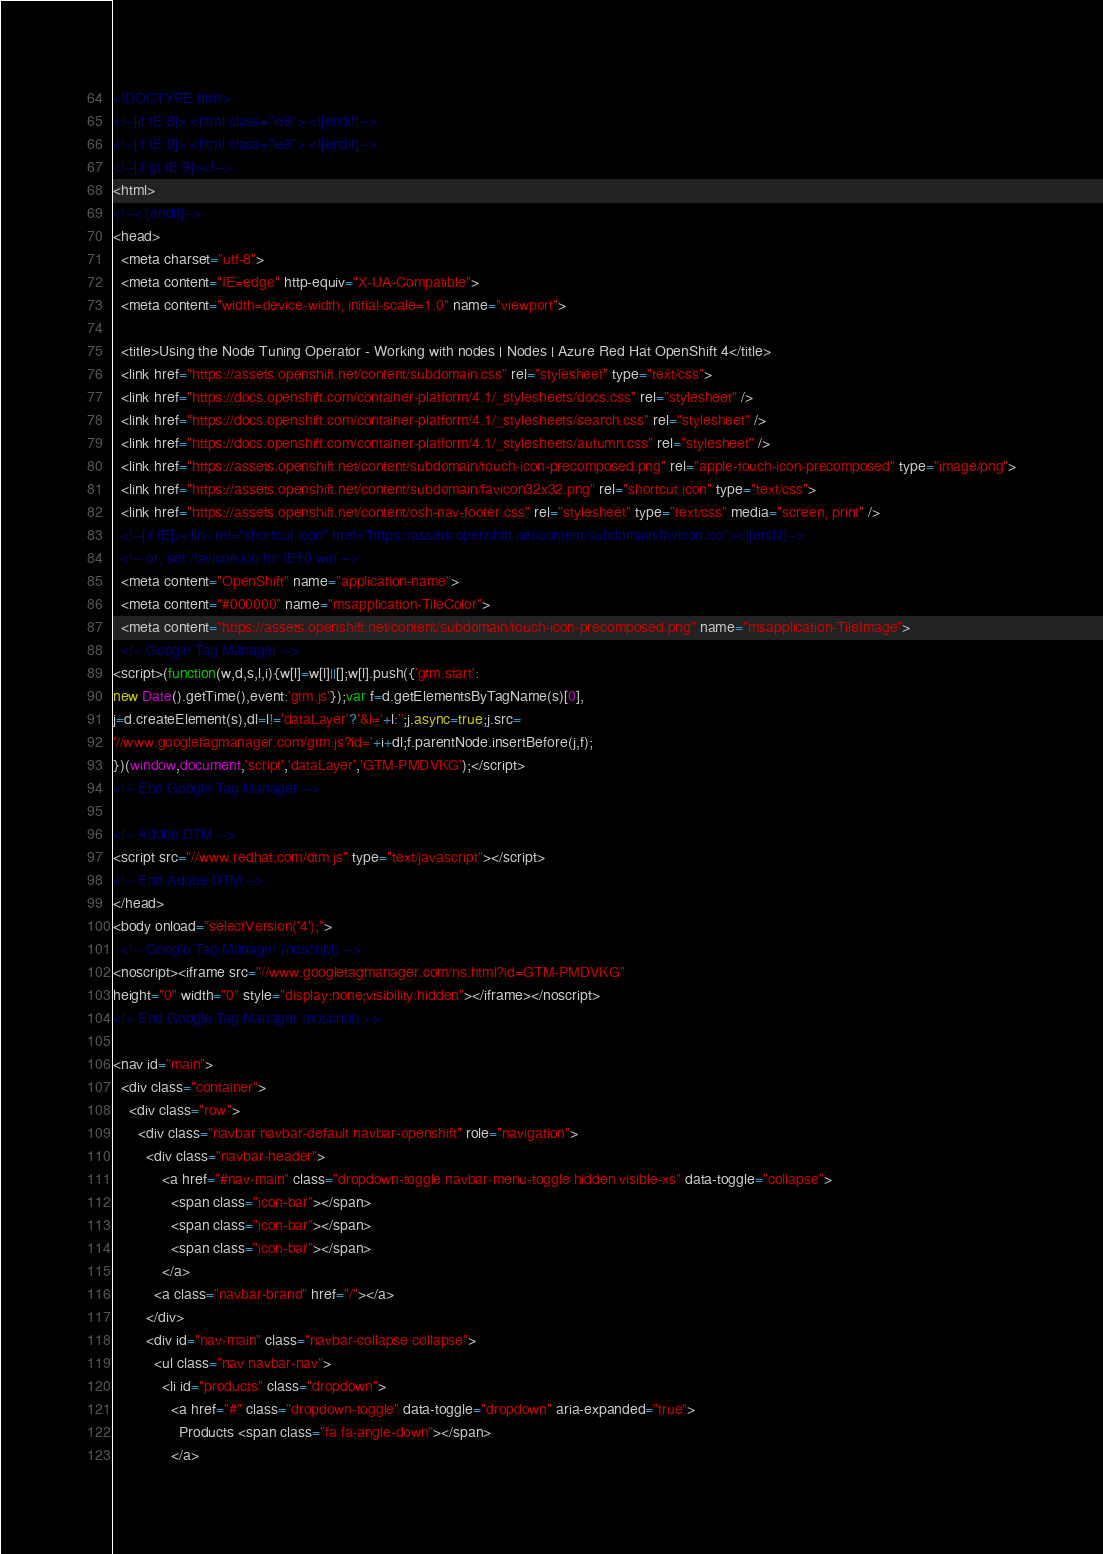Convert code to text. <code><loc_0><loc_0><loc_500><loc_500><_HTML_>

<!DOCTYPE html>
<!--[if IE 8]> <html class="ie8"> <![endif]-->
<!--[if IE 9]> <html class="ie9"> <![endif]-->
<!--[if gt IE 9]><!-->
<html>
<!--<![endif]-->
<head>
  <meta charset="utf-8">
  <meta content="IE=edge" http-equiv="X-UA-Compatible">
  <meta content="width=device-width, initial-scale=1.0" name="viewport">
  
  <title>Using the Node Tuning Operator - Working with nodes | Nodes | Azure Red Hat OpenShift 4</title>
  <link href="https://assets.openshift.net/content/subdomain.css" rel="stylesheet" type="text/css">
  <link href="https://docs.openshift.com/container-platform/4.1/_stylesheets/docs.css" rel="stylesheet" />
  <link href="https://docs.openshift.com/container-platform/4.1/_stylesheets/search.css" rel="stylesheet" />
  <link href="https://docs.openshift.com/container-platform/4.1/_stylesheets/autumn.css" rel="stylesheet" />
  <link href="https://assets.openshift.net/content/subdomain/touch-icon-precomposed.png" rel="apple-touch-icon-precomposed" type="image/png">
  <link href="https://assets.openshift.net/content/subdomain/favicon32x32.png" rel="shortcut icon" type="text/css">
  <link href="https://assets.openshift.net/content/osh-nav-footer.css" rel="stylesheet" type="text/css" media="screen, print" />
  <!--[if IE]><link rel="shortcut icon" href="https://assets.openshift.net/content/subdomain/favicon.ico"><![endif]-->
  <!-- or, set /favicon.ico for IE10 win -->
  <meta content="OpenShift" name="application-name">
  <meta content="#000000" name="msapplication-TileColor">
  <meta content="https://assets.openshift.net/content/subdomain/touch-icon-precomposed.png" name="msapplication-TileImage">
  <!-- Google Tag Manager -->
<script>(function(w,d,s,l,i){w[l]=w[l]||[];w[l].push({'gtm.start':
new Date().getTime(),event:'gtm.js'});var f=d.getElementsByTagName(s)[0],
j=d.createElement(s),dl=l!='dataLayer'?'&l='+l:'';j.async=true;j.src=
'//www.googletagmanager.com/gtm.js?id='+i+dl;f.parentNode.insertBefore(j,f);
})(window,document,'script','dataLayer','GTM-PMDVKG');</script>
<!-- End Google Tag Manager -->

<!-- Adobe DTM -->
<script src="//www.redhat.com/dtm.js" type="text/javascript"></script>
<!-- End Adobe DTM -->
</head>
<body onload="selectVersion('4');">
  <!-- Google Tag Manager (noscript) -->
<noscript><iframe src="//www.googletagmanager.com/ns.html?id=GTM-PMDVKG"
height="0" width="0" style="display:none;visibility:hidden"></iframe></noscript>
<!-- End Google Tag Manager (noscript) -->

<nav id="main">
  <div class="container">
    <div class="row">
      <div class="navbar navbar-default navbar-openshift" role="navigation">
        <div class="navbar-header">
            <a href="#nav-main" class="dropdown-toggle navbar-menu-toggle hidden visible-xs" data-toggle="collapse">
              <span class="icon-bar"></span>
              <span class="icon-bar"></span>
              <span class="icon-bar"></span>
            </a>
          <a class="navbar-brand" href="/"></a>
        </div>
        <div id="nav-main" class="navbar-collapse collapse">
          <ul class="nav navbar-nav">
            <li id="products" class="dropdown">
              <a href="#" class="dropdown-toggle" data-toggle="dropdown" aria-expanded="true">
                Products <span class="fa fa-angle-down"></span>
              </a></code> 